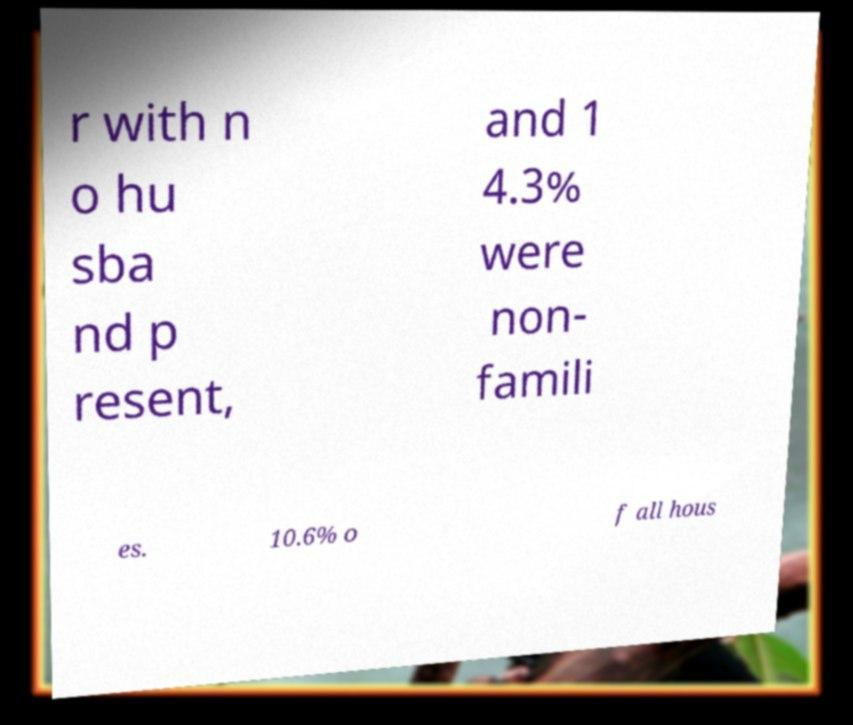There's text embedded in this image that I need extracted. Can you transcribe it verbatim? r with n o hu sba nd p resent, and 1 4.3% were non- famili es. 10.6% o f all hous 